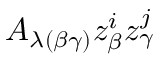Convert formula to latex. <formula><loc_0><loc_0><loc_500><loc_500>A _ { \lambda ( \beta \gamma ) } z _ { \beta } ^ { i } z _ { \gamma } ^ { j }</formula> 